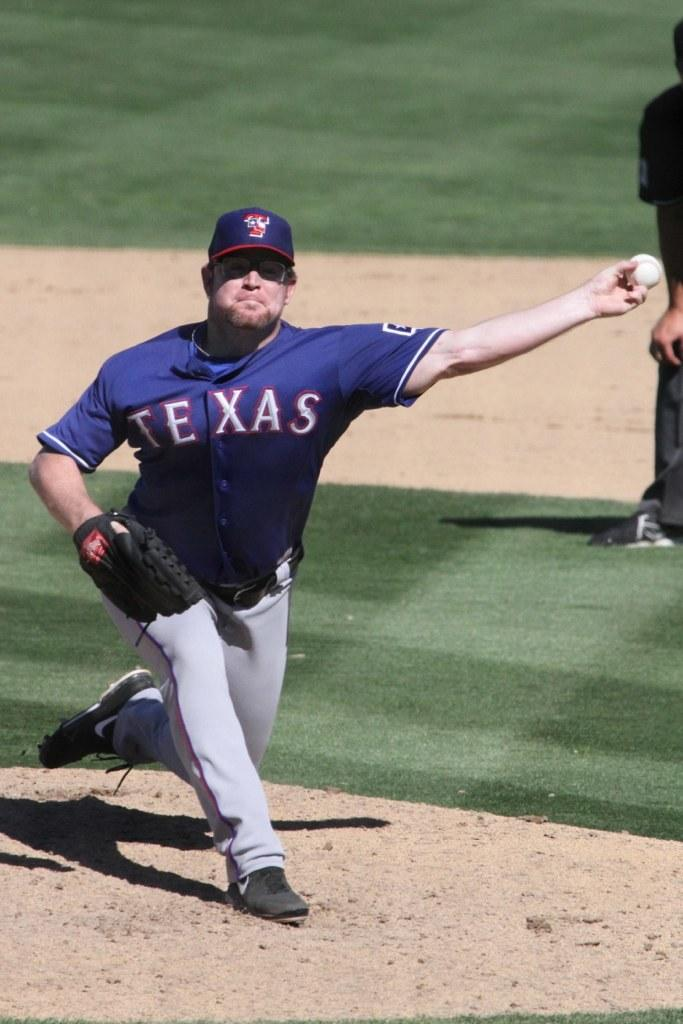<image>
Share a concise interpretation of the image provided. A pitcher with a blue and gray uniform with the texas logo is in the process of throwing a ball. 